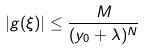Convert formula to latex. <formula><loc_0><loc_0><loc_500><loc_500>| g ( \xi ) | \leq \frac { M } { ( y _ { 0 } + \lambda ) ^ { N } }</formula> 